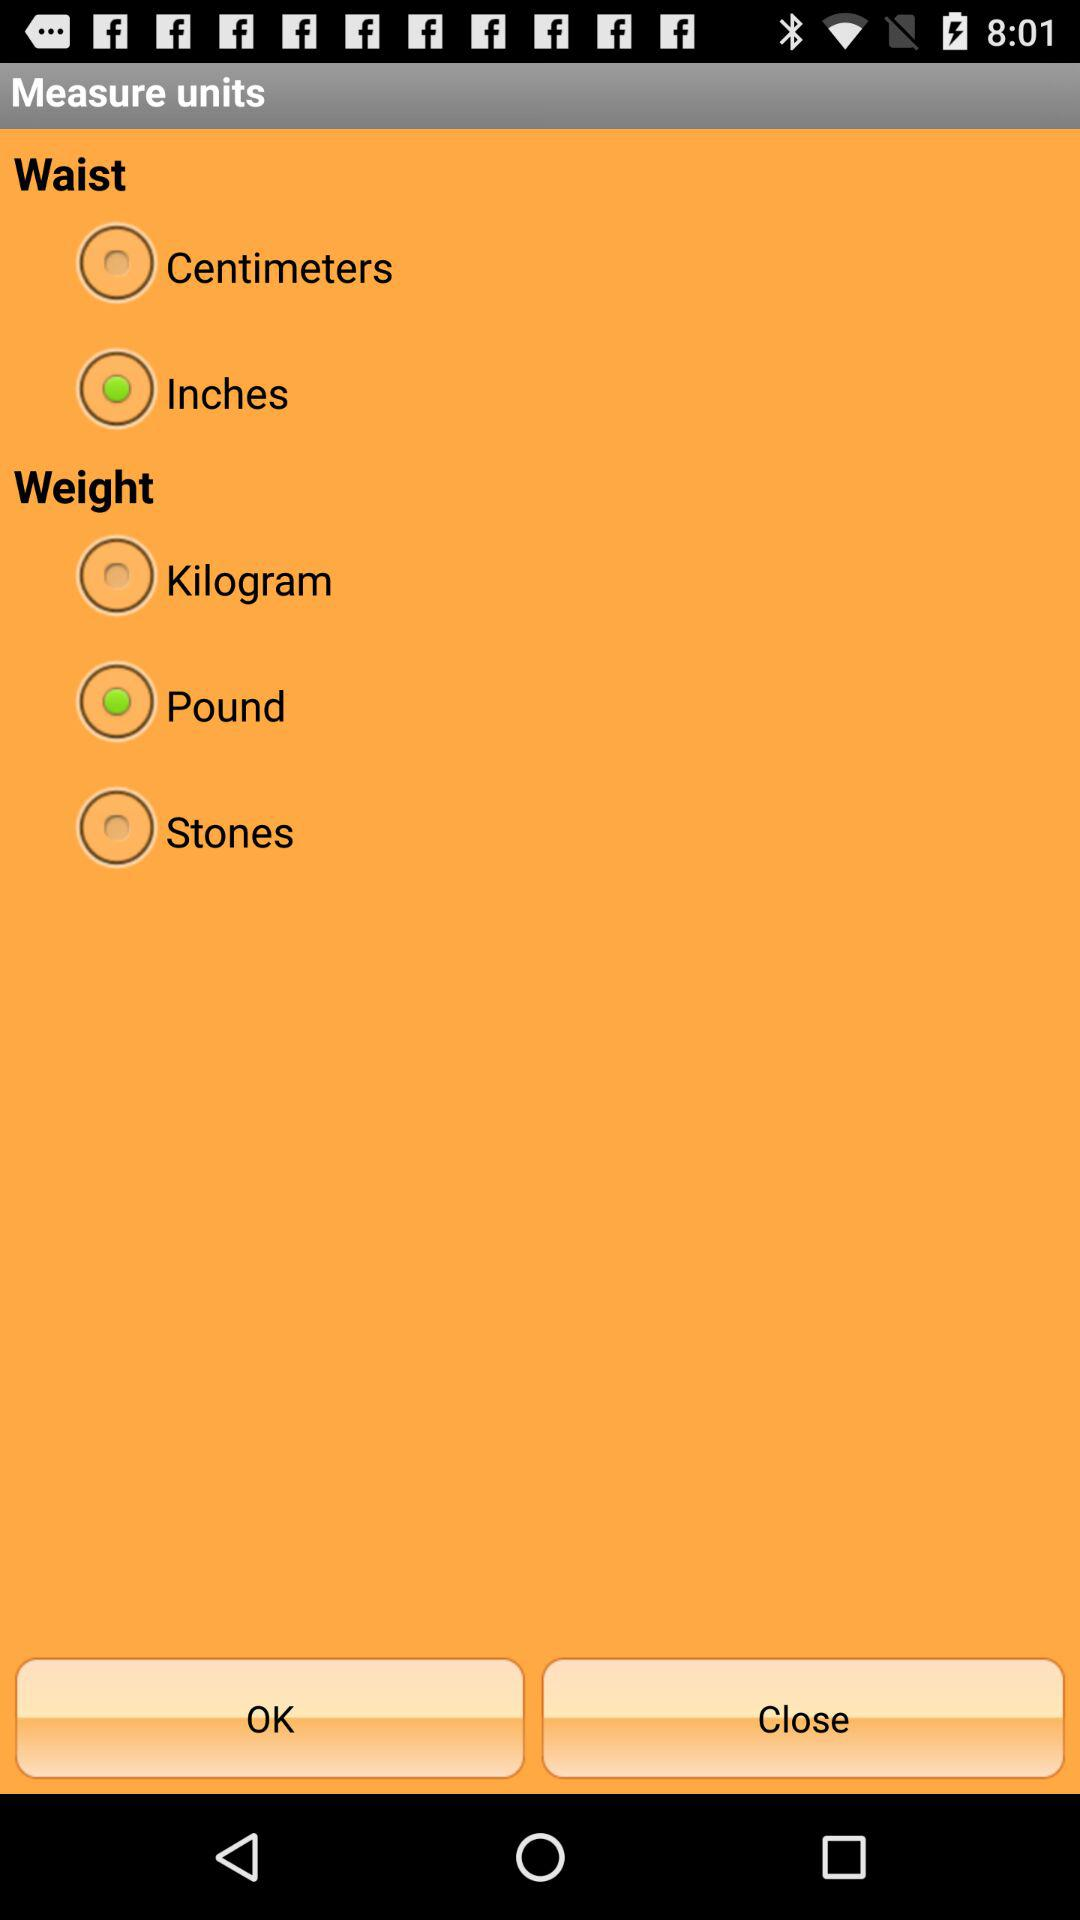Which unit is selected for measuring the waist? The selected unit for measuring the waist is inches. 